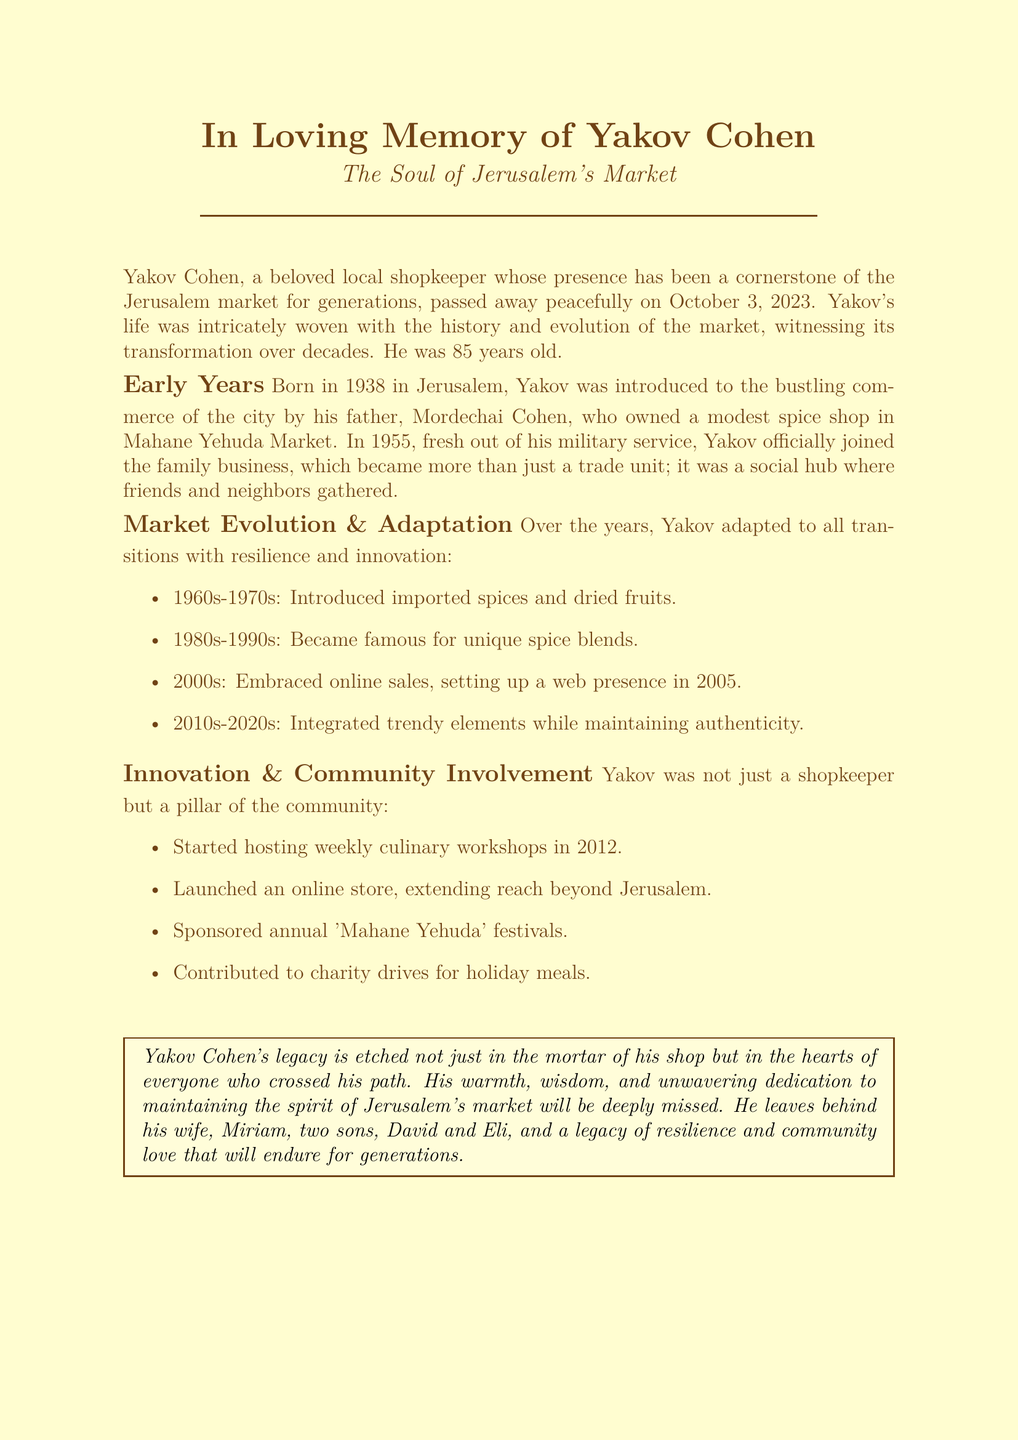What was Yakov Cohen's father’s name? The document states that Yakov's father's name was Mordechai Cohen.
Answer: Mordechai Cohen When did Yakov Cohen officially join the family business? The document mentions Yakov joined the family business in 1955.
Answer: 1955 What was introduced by Yakov in the 2000s? The document indicates that Yakov embraced online sales in the 2000s, specifically in 2005.
Answer: Online sales How many sons did Yakov Cohen have? The document lists that Yakov leaves behind two sons, David and Eli.
Answer: Two What kind of workshops did Yakov start hosting in 2012? The document states he started hosting weekly culinary workshops.
Answer: Culinary workshops What event did Yakov sponsor annually? According to the document, Yakov sponsored the 'Mahane Yehuda' festivals each year.
Answer: 'Mahane Yehuda' festivals What is termed as Yakov’s legacy in the document? The document describes Yakov's legacy as one of resilience and community love.
Answer: Resilience and community love In what year was Yakov Cohen born? The document provides Yakov's birth year as 1938.
Answer: 1938 